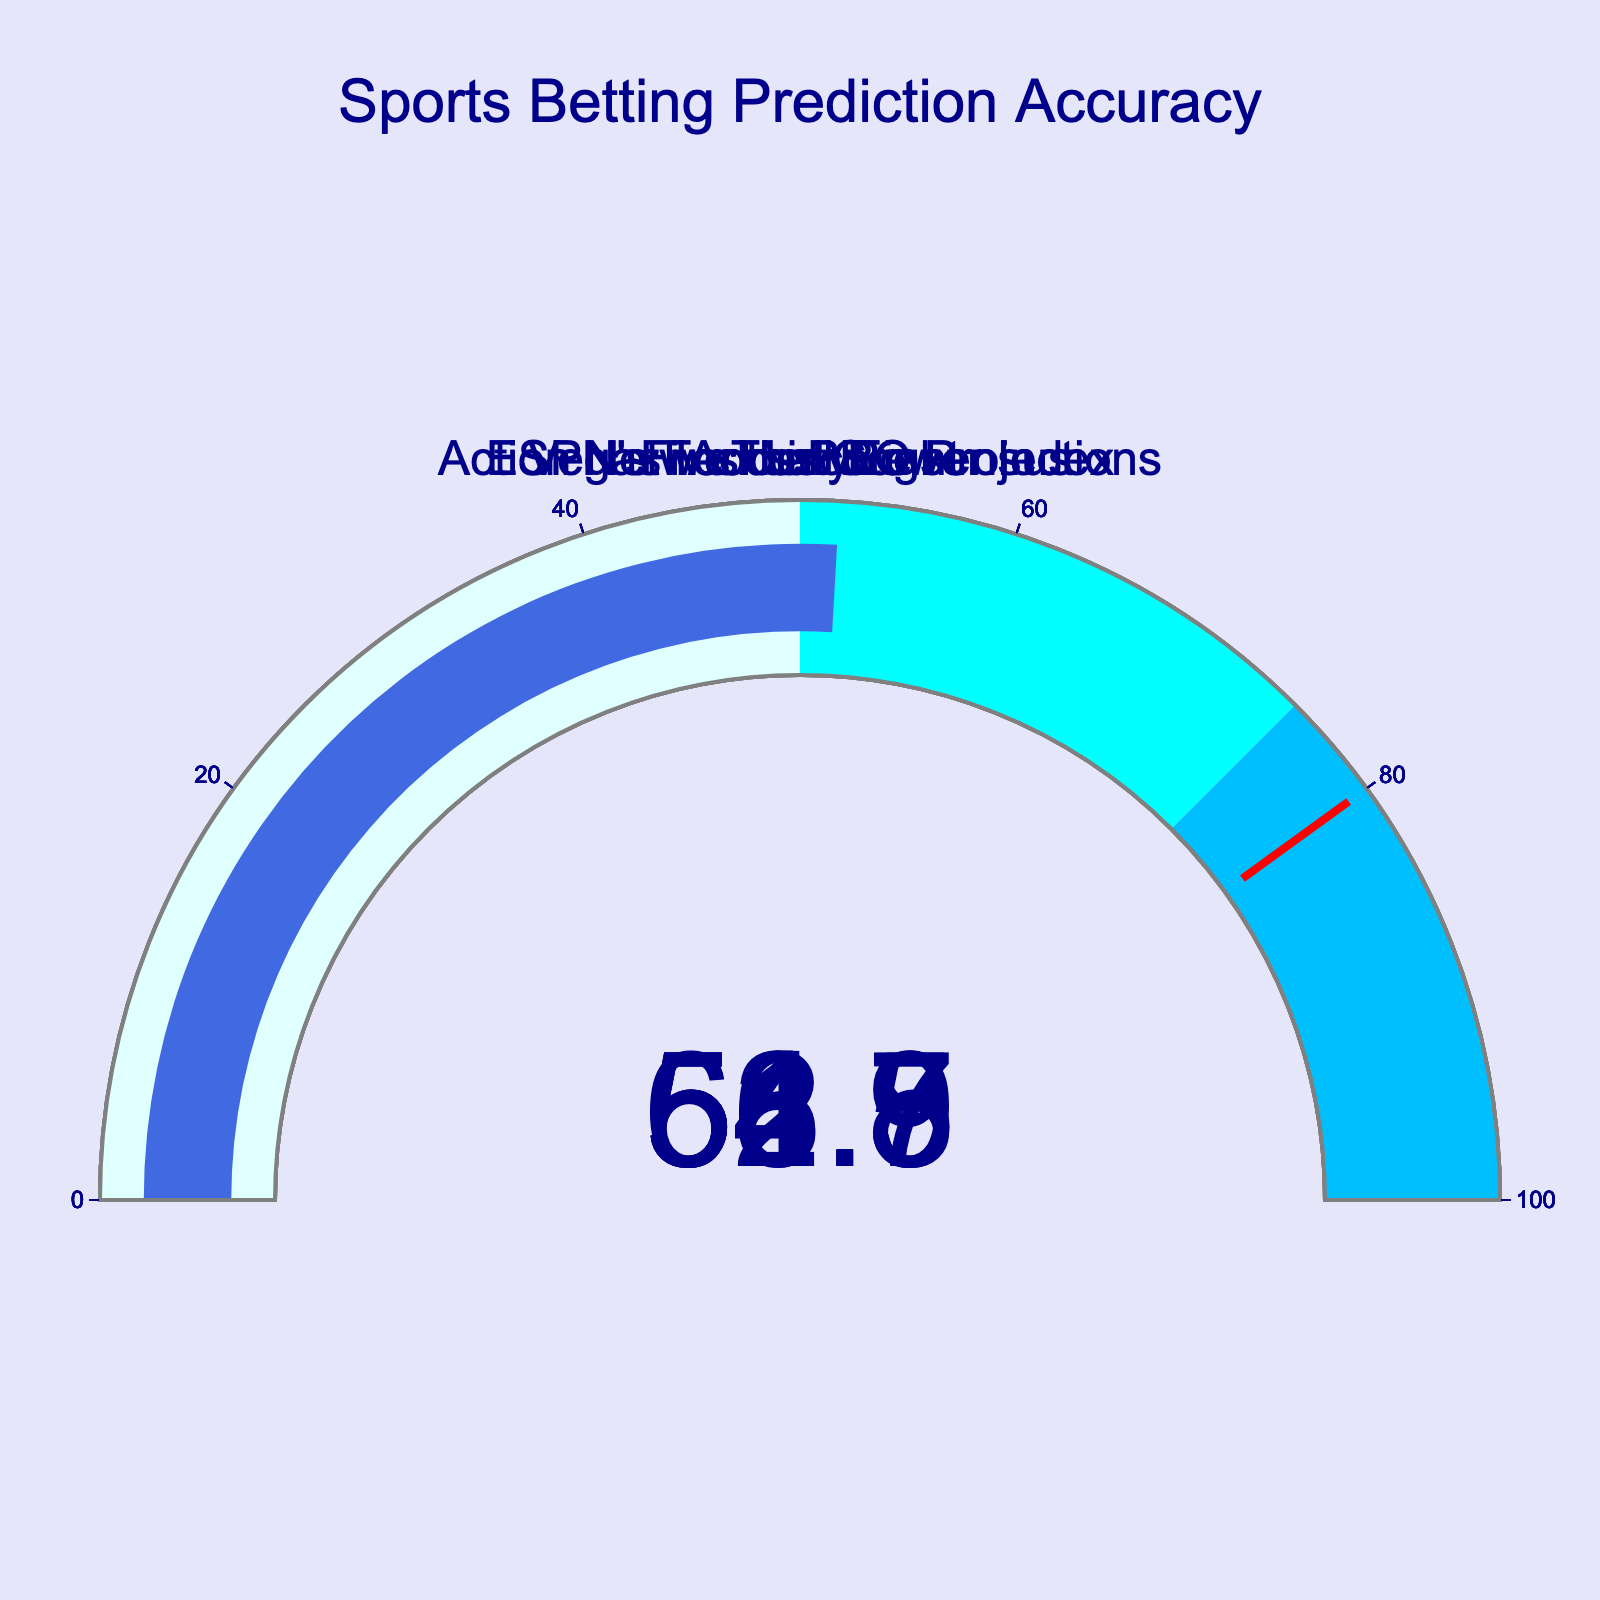What is the highest accuracy displayed on the chart? The gauge chart shows the accuracy of different statistical models for sports betting. By looking at each gauge, the model with the highest accuracy is identified. The highest value is 62.5% for FiveThirtyEight.
Answer: 62.5% What is the lowest accuracy displayed on the chart? The gauge chart shows the accuracy of different statistical models. To find the lowest accuracy, check each gauge and identify the smallest value. The lowest is 51.8% for Vegas Insider Consensus.
Answer: 51.8% Which model has the second-highest accuracy? To determine the model with the second-highest accuracy, find the highest value first which is 62.5% for FiveThirtyEight. Then identify the next highest value, which is 58.9% for ESPN's Football Power Index.
Answer: ESPN's Football Power Index What is the average accuracy of all models displayed? First, sum the accuracy percentages: 62.5 + 58.9 + 56.7 + 54.3 + 51.8 = 284.2. Then divide by the number of models: 284.2 / 5 = 56.84.
Answer: 56.84% How many models have an accuracy of over 55%? Check each gauge to see if the accuracy is greater than 55%. The models that meet this criterion are FiveThirtyEight (62.5%), ESPN's Football Power Index (58.9%), and Action Network's PRO Projections (56.7%). That makes three models.
Answer: 3 Which model is closest to a 50% accuracy threshold? Compare the accuracy of each model to the 50% mark. The model closest to this threshold but still above 50% is Vegas Insider Consensus with 51.8%.
Answer: Vegas Insider Consensus How much higher is the highest accuracy compared to the lowest accuracy? First, identify the highest accuracy (62.5%) and the lowest accuracy (51.8%). Then subtract the lowest from the highest: 62.5 - 51.8 = 10.7.
Answer: 10.7 Which models have more than 5% better accuracy than Accuscore? Accuscore has an accuracy of 54.3%. Adding 5% gives us 59.3%. The models with accuracy higher than 59.3% are FiveThirtyEight (62.5%) and ESPN's Football Power Index (58.9%). Therefore, no models meet this criterion.
Answer: None Arrange the models in descending order of their accuracy. The order of the models based on their accuracy from highest to lowest is: FiveThirtyEight (62.5%), ESPN's Football Power Index (58.9%), Action Network's PRO Projections (56.7%), Accuscore (54.3%), Vegas Insider Consensus (51.8%).
Answer: FiveThirtyEight, ESPN's Football Power Index, Action Network's PRO Projections, Accuscore, Vegas Insider Consensus 